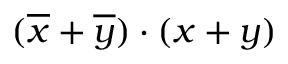Convert formula to latex. <formula><loc_0><loc_0><loc_500><loc_500>( { \overline { x } } + { \overline { y } } ) \cdot ( x + y )</formula> 